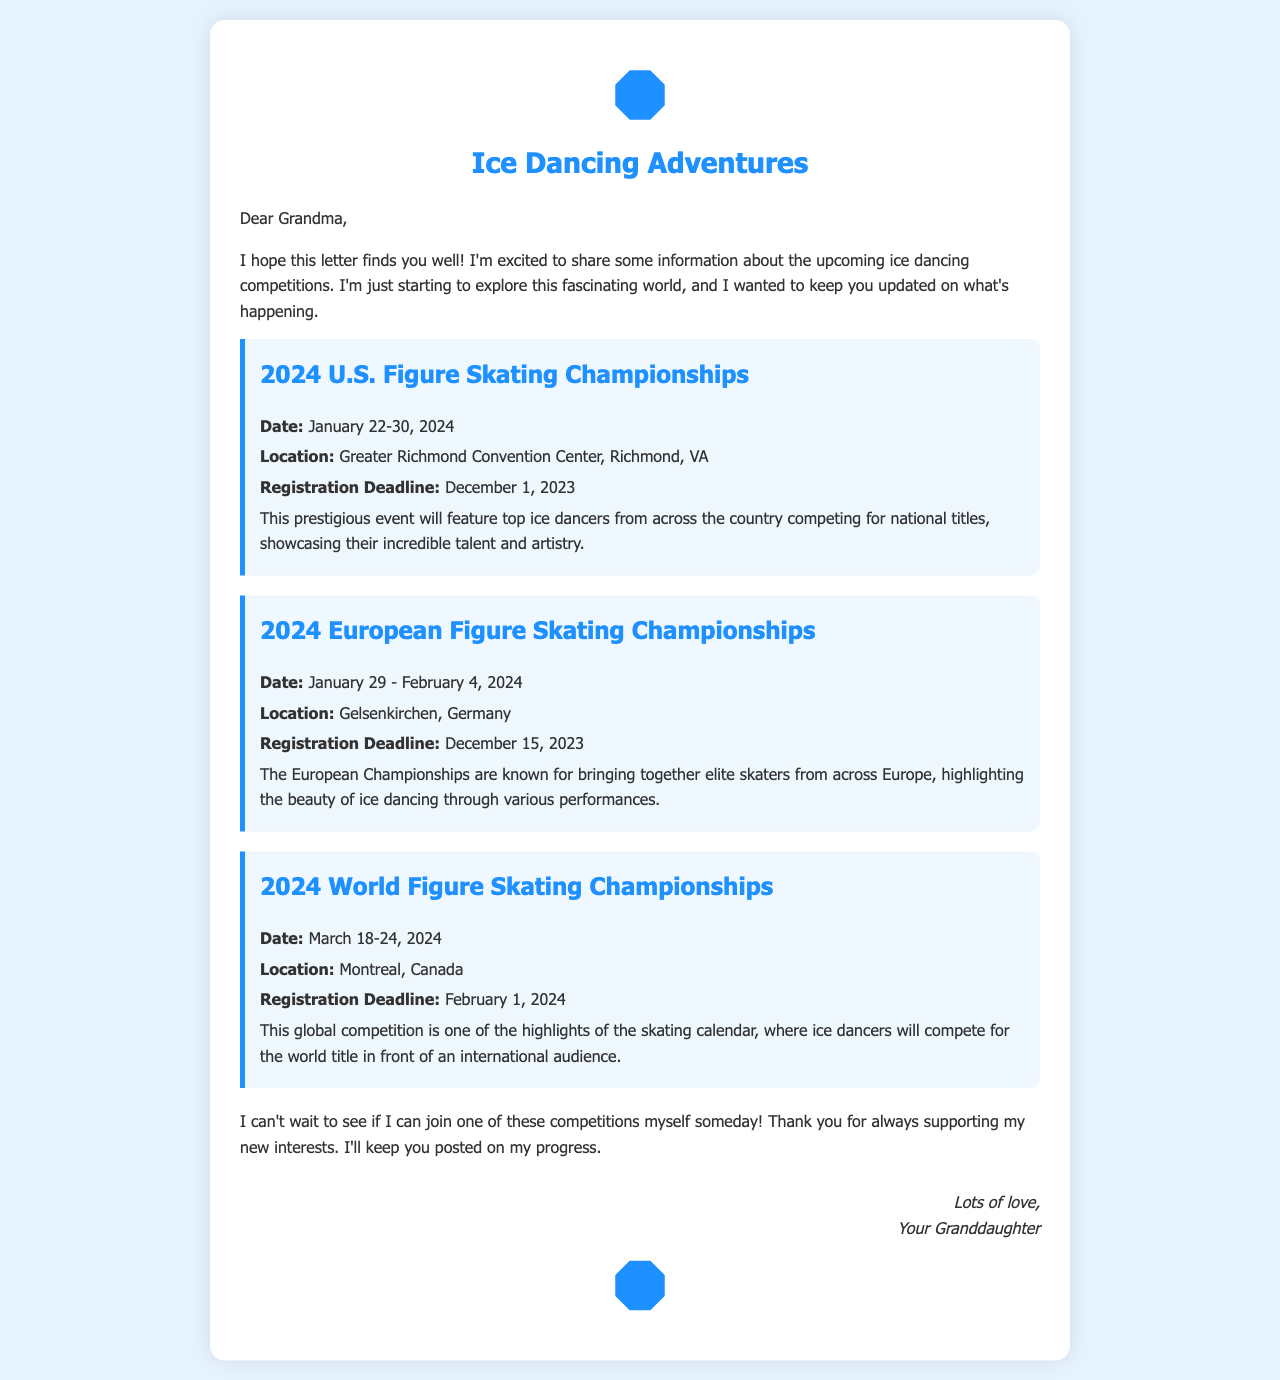what is the date of the 2024 U.S. Figure Skating Championships? The date for the 2024 U.S. Figure Skating Championships is mentioned as January 22-30, 2024.
Answer: January 22-30, 2024 where will the 2024 World Figure Skating Championships be held? The location for the 2024 World Figure Skating Championships is stated as Montreal, Canada.
Answer: Montreal, Canada when is the registration deadline for the 2024 European Figure Skating Championships? The registration deadline for the 2024 European Championships is noted as December 15, 2023.
Answer: December 15, 2023 what is the primary focus of the 2024 U.S. Figure Skating Championships? The document describes the event as featuring top ice dancers from across the country competing for national titles.
Answer: Competing for national titles how many days does the 2024 World Figure Skating Championships last? The document specifies that the championship lasts from March 18-24, 2024, which is 7 days.
Answer: 7 days what kind of performance is highlighted at the European Championships? The document mentions that the European Championships highlight the beauty of ice dancing through various performances.
Answer: Beauty of ice dancing who is writing this letter? The letter is written by the granddaughter, as indicated at the end of the document.
Answer: Your Granddaughter what event occurs right before the World Figure Skating Championships? The schedule indicates that the 2024 European Championships occur from January 29 - February 4, 2024, right before the World Championships.
Answer: 2024 European Championships 